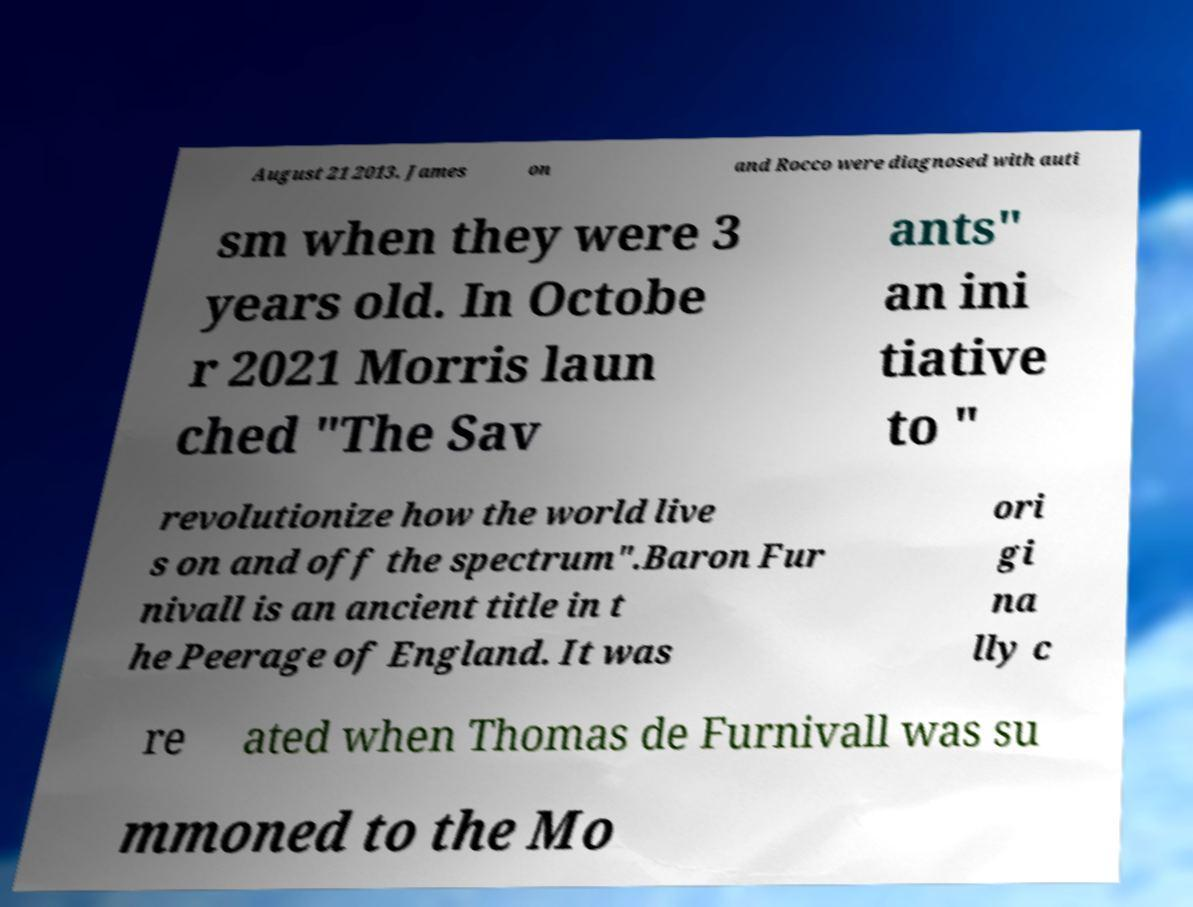What messages or text are displayed in this image? I need them in a readable, typed format. August 21 2013. James on and Rocco were diagnosed with auti sm when they were 3 years old. In Octobe r 2021 Morris laun ched "The Sav ants" an ini tiative to " revolutionize how the world live s on and off the spectrum".Baron Fur nivall is an ancient title in t he Peerage of England. It was ori gi na lly c re ated when Thomas de Furnivall was su mmoned to the Mo 